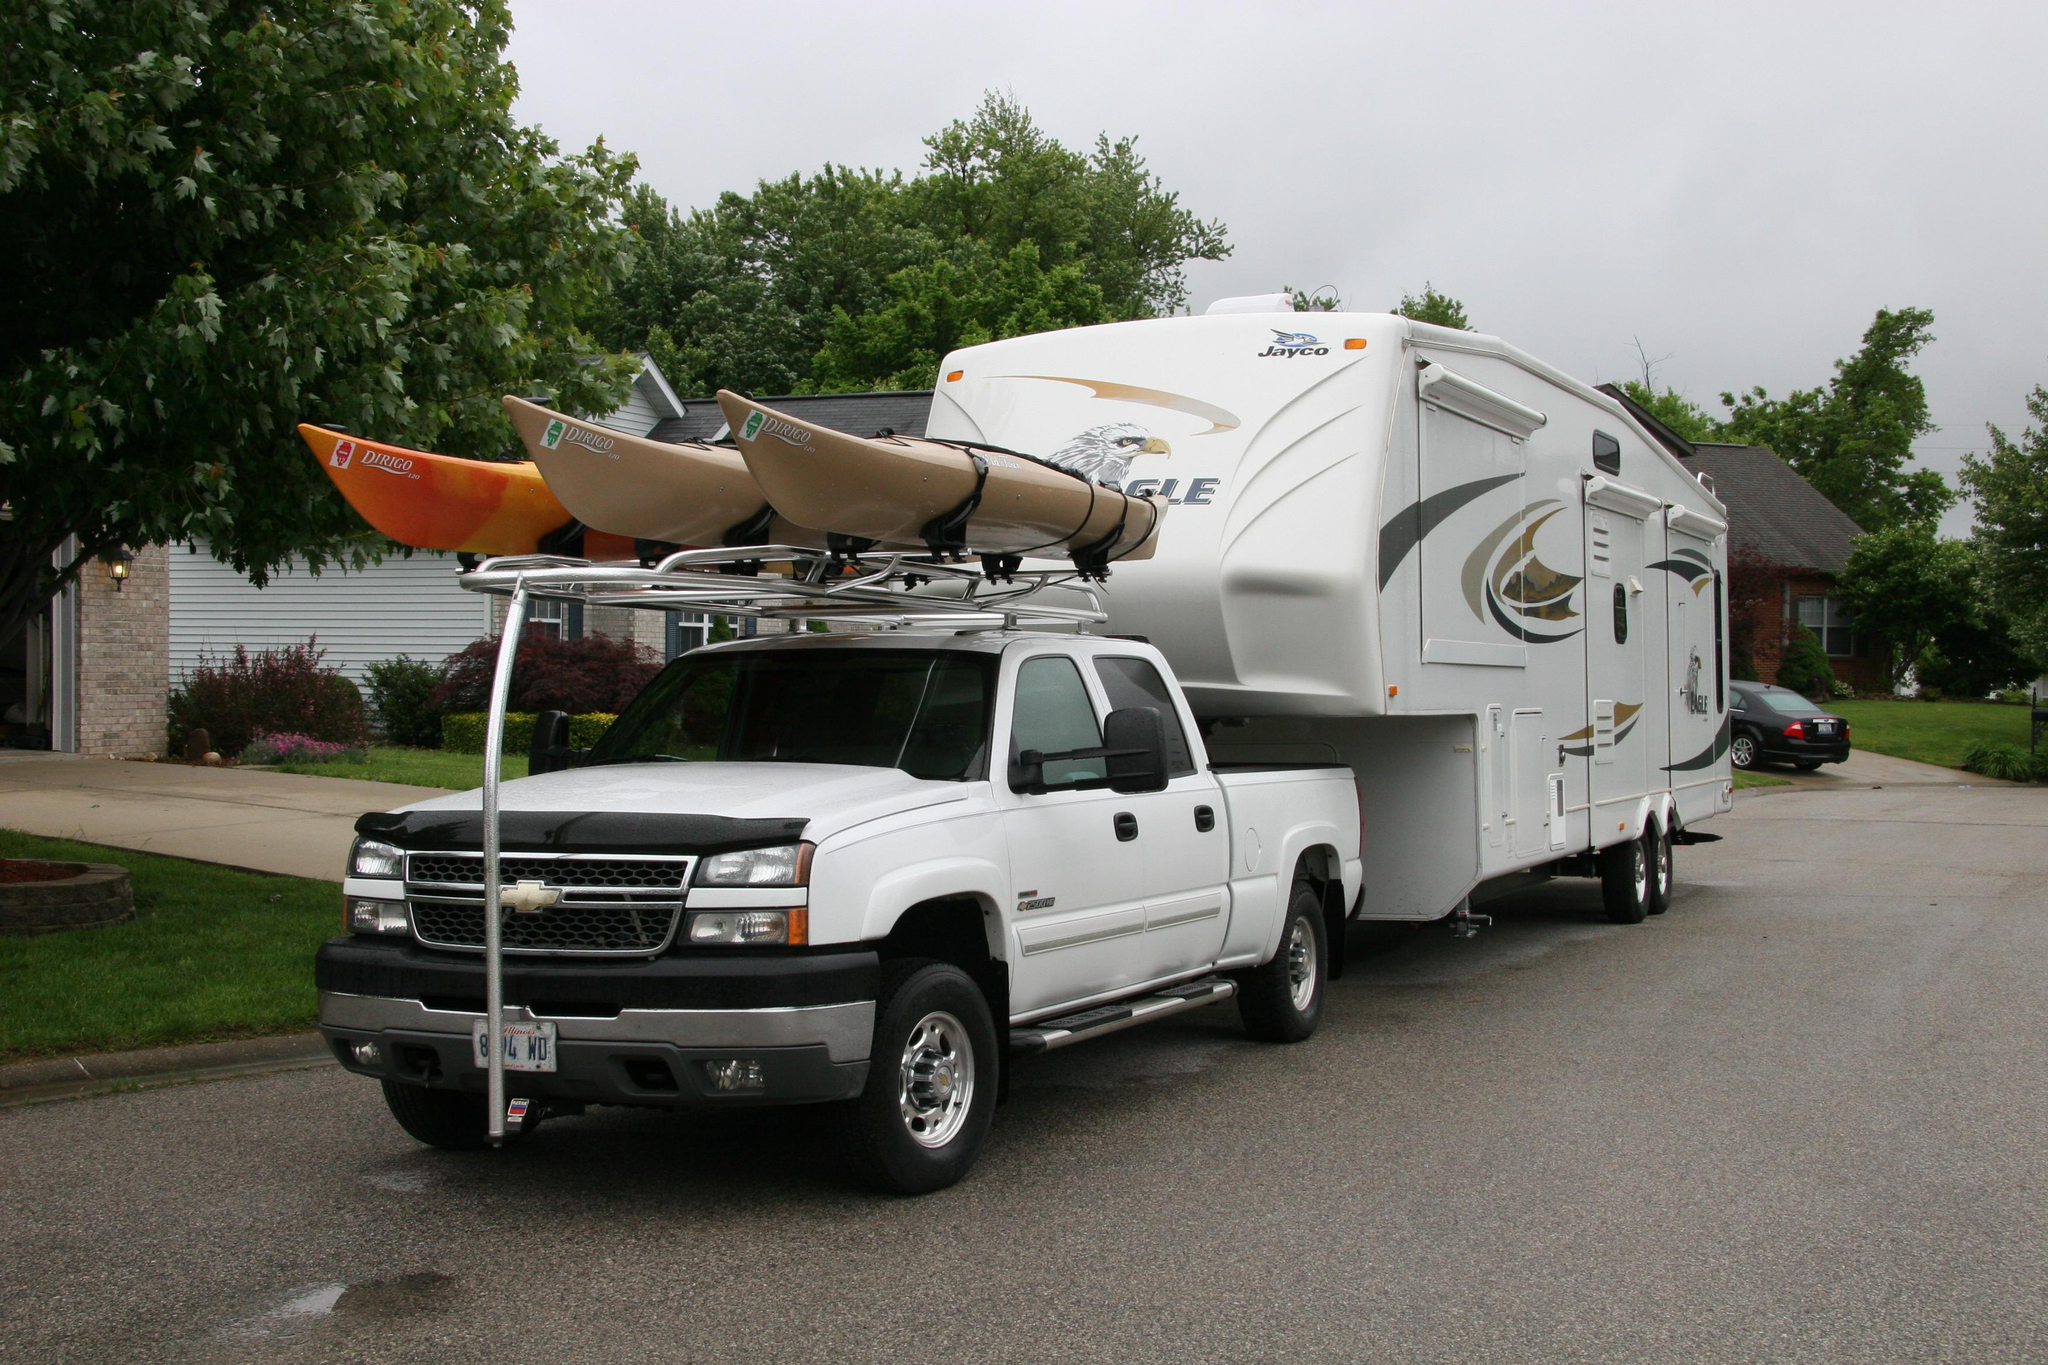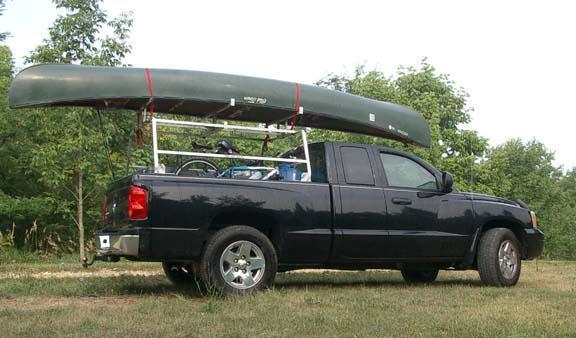The first image is the image on the left, the second image is the image on the right. Examine the images to the left and right. Is the description "One of the images contains at least one red kayak." accurate? Answer yes or no. Yes. 